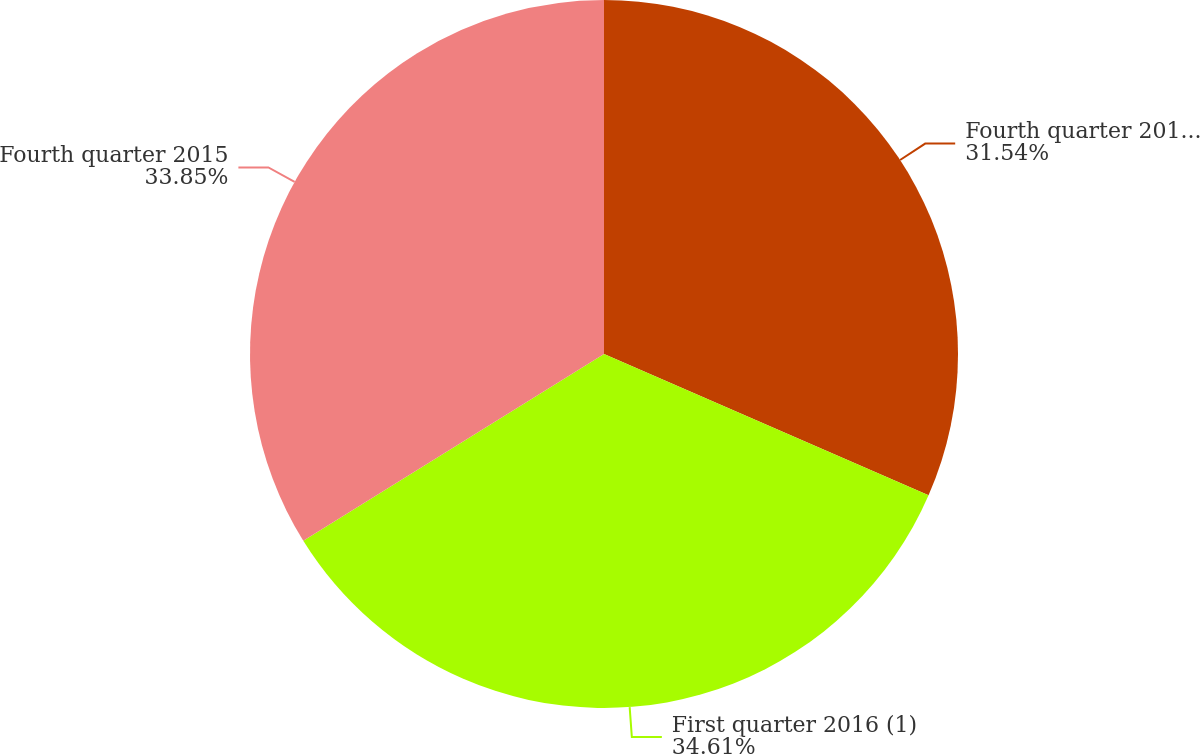<chart> <loc_0><loc_0><loc_500><loc_500><pie_chart><fcel>Fourth quarter 2016 (1)<fcel>First quarter 2016 (1)<fcel>Fourth quarter 2015<nl><fcel>31.54%<fcel>34.62%<fcel>33.85%<nl></chart> 